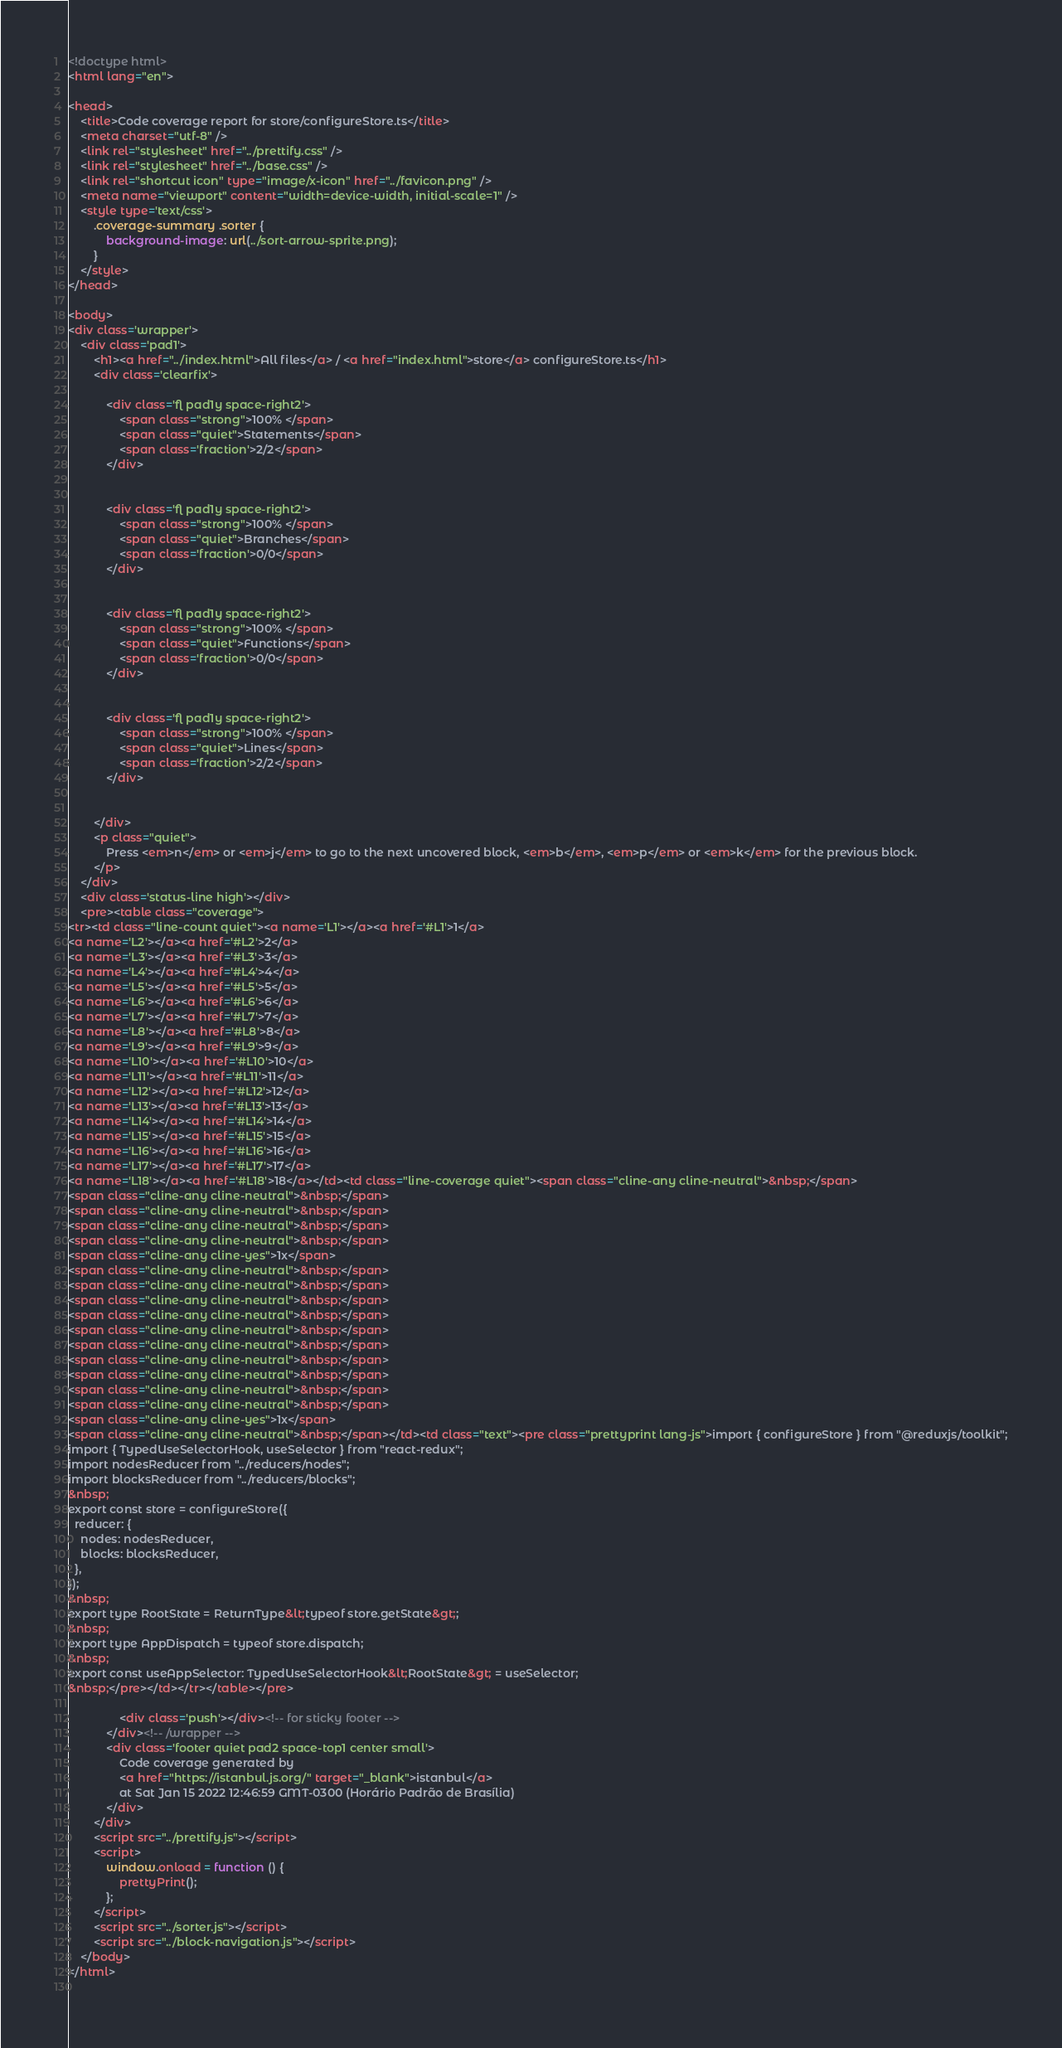Convert code to text. <code><loc_0><loc_0><loc_500><loc_500><_HTML_>
<!doctype html>
<html lang="en">

<head>
    <title>Code coverage report for store/configureStore.ts</title>
    <meta charset="utf-8" />
    <link rel="stylesheet" href="../prettify.css" />
    <link rel="stylesheet" href="../base.css" />
    <link rel="shortcut icon" type="image/x-icon" href="../favicon.png" />
    <meta name="viewport" content="width=device-width, initial-scale=1" />
    <style type='text/css'>
        .coverage-summary .sorter {
            background-image: url(../sort-arrow-sprite.png);
        }
    </style>
</head>
    
<body>
<div class='wrapper'>
    <div class='pad1'>
        <h1><a href="../index.html">All files</a> / <a href="index.html">store</a> configureStore.ts</h1>
        <div class='clearfix'>
            
            <div class='fl pad1y space-right2'>
                <span class="strong">100% </span>
                <span class="quiet">Statements</span>
                <span class='fraction'>2/2</span>
            </div>
        
            
            <div class='fl pad1y space-right2'>
                <span class="strong">100% </span>
                <span class="quiet">Branches</span>
                <span class='fraction'>0/0</span>
            </div>
        
            
            <div class='fl pad1y space-right2'>
                <span class="strong">100% </span>
                <span class="quiet">Functions</span>
                <span class='fraction'>0/0</span>
            </div>
        
            
            <div class='fl pad1y space-right2'>
                <span class="strong">100% </span>
                <span class="quiet">Lines</span>
                <span class='fraction'>2/2</span>
            </div>
        
            
        </div>
        <p class="quiet">
            Press <em>n</em> or <em>j</em> to go to the next uncovered block, <em>b</em>, <em>p</em> or <em>k</em> for the previous block.
        </p>
    </div>
    <div class='status-line high'></div>
    <pre><table class="coverage">
<tr><td class="line-count quiet"><a name='L1'></a><a href='#L1'>1</a>
<a name='L2'></a><a href='#L2'>2</a>
<a name='L3'></a><a href='#L3'>3</a>
<a name='L4'></a><a href='#L4'>4</a>
<a name='L5'></a><a href='#L5'>5</a>
<a name='L6'></a><a href='#L6'>6</a>
<a name='L7'></a><a href='#L7'>7</a>
<a name='L8'></a><a href='#L8'>8</a>
<a name='L9'></a><a href='#L9'>9</a>
<a name='L10'></a><a href='#L10'>10</a>
<a name='L11'></a><a href='#L11'>11</a>
<a name='L12'></a><a href='#L12'>12</a>
<a name='L13'></a><a href='#L13'>13</a>
<a name='L14'></a><a href='#L14'>14</a>
<a name='L15'></a><a href='#L15'>15</a>
<a name='L16'></a><a href='#L16'>16</a>
<a name='L17'></a><a href='#L17'>17</a>
<a name='L18'></a><a href='#L18'>18</a></td><td class="line-coverage quiet"><span class="cline-any cline-neutral">&nbsp;</span>
<span class="cline-any cline-neutral">&nbsp;</span>
<span class="cline-any cline-neutral">&nbsp;</span>
<span class="cline-any cline-neutral">&nbsp;</span>
<span class="cline-any cline-neutral">&nbsp;</span>
<span class="cline-any cline-yes">1x</span>
<span class="cline-any cline-neutral">&nbsp;</span>
<span class="cline-any cline-neutral">&nbsp;</span>
<span class="cline-any cline-neutral">&nbsp;</span>
<span class="cline-any cline-neutral">&nbsp;</span>
<span class="cline-any cline-neutral">&nbsp;</span>
<span class="cline-any cline-neutral">&nbsp;</span>
<span class="cline-any cline-neutral">&nbsp;</span>
<span class="cline-any cline-neutral">&nbsp;</span>
<span class="cline-any cline-neutral">&nbsp;</span>
<span class="cline-any cline-neutral">&nbsp;</span>
<span class="cline-any cline-yes">1x</span>
<span class="cline-any cline-neutral">&nbsp;</span></td><td class="text"><pre class="prettyprint lang-js">import { configureStore } from "@reduxjs/toolkit";
import { TypedUseSelectorHook, useSelector } from "react-redux";
import nodesReducer from "../reducers/nodes";
import blocksReducer from "../reducers/blocks";
&nbsp;
export const store = configureStore({
  reducer: {
    nodes: nodesReducer,
    blocks: blocksReducer,
  },
});
&nbsp;
export type RootState = ReturnType&lt;typeof store.getState&gt;;
&nbsp;
export type AppDispatch = typeof store.dispatch;
&nbsp;
export const useAppSelector: TypedUseSelectorHook&lt;RootState&gt; = useSelector;
&nbsp;</pre></td></tr></table></pre>

                <div class='push'></div><!-- for sticky footer -->
            </div><!-- /wrapper -->
            <div class='footer quiet pad2 space-top1 center small'>
                Code coverage generated by
                <a href="https://istanbul.js.org/" target="_blank">istanbul</a>
                at Sat Jan 15 2022 12:46:59 GMT-0300 (Horário Padrão de Brasília)
            </div>
        </div>
        <script src="../prettify.js"></script>
        <script>
            window.onload = function () {
                prettyPrint();
            };
        </script>
        <script src="../sorter.js"></script>
        <script src="../block-navigation.js"></script>
    </body>
</html>
    </code> 